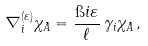Convert formula to latex. <formula><loc_0><loc_0><loc_500><loc_500>\nabla ^ { ( \varepsilon ) } _ { i } \chi _ { A } = \frac { \i i \varepsilon } { \ell } \, \gamma _ { i } \chi _ { A } \, ,</formula> 